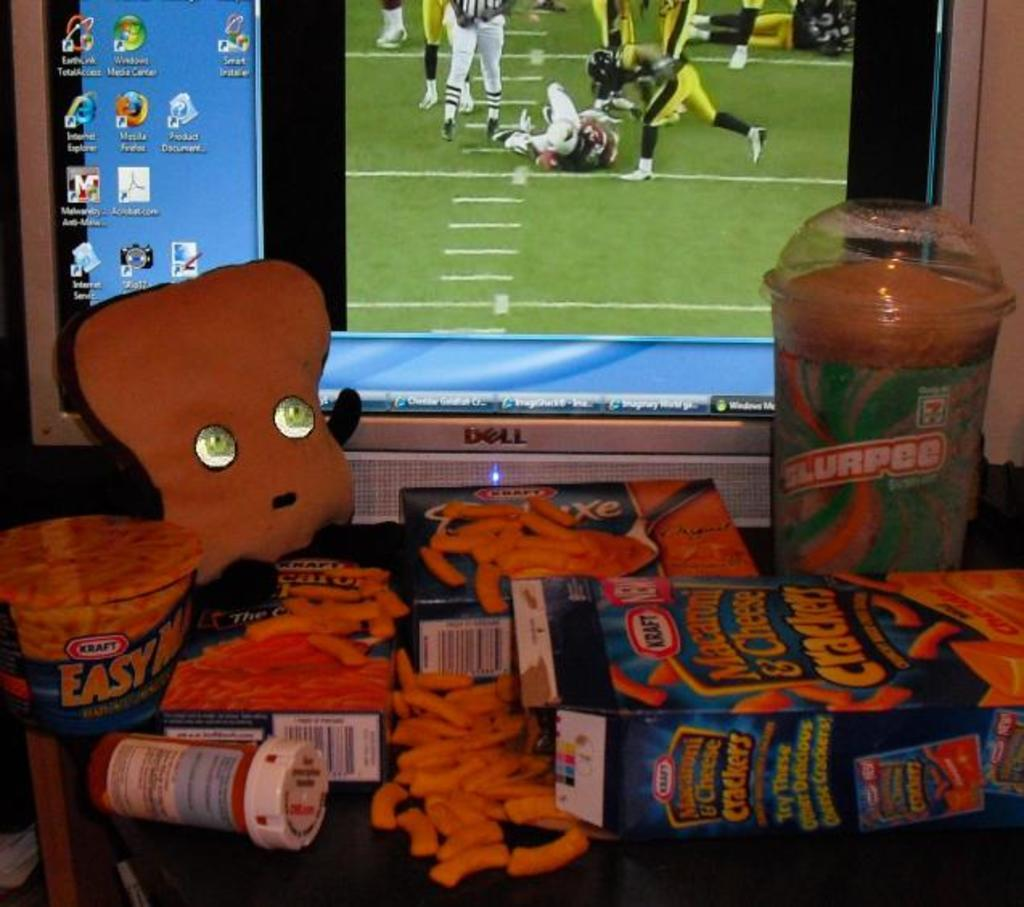<image>
Present a compact description of the photo's key features. A spilled box of Macaroni and Cheese Crackers next to a 7-11 Slurpee and an unopened box of Kraft Easy Mac. 